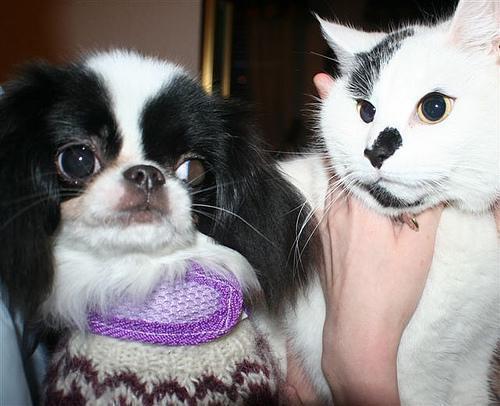How many cats are shown here?
Select the correct answer and articulate reasoning with the following format: 'Answer: answer
Rationale: rationale.'
Options: Three, two, one, four. Answer: one.
Rationale: The picture shows two animals; a dog on the left and a cat on the right. 